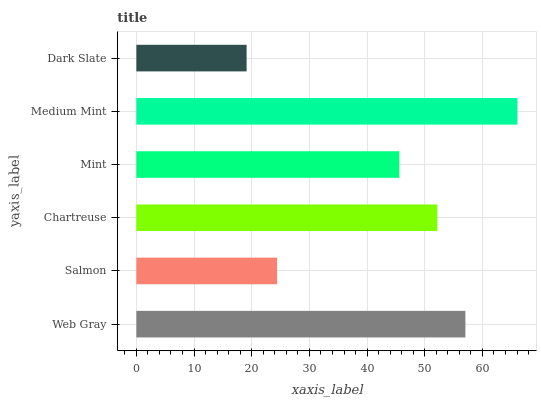Is Dark Slate the minimum?
Answer yes or no. Yes. Is Medium Mint the maximum?
Answer yes or no. Yes. Is Salmon the minimum?
Answer yes or no. No. Is Salmon the maximum?
Answer yes or no. No. Is Web Gray greater than Salmon?
Answer yes or no. Yes. Is Salmon less than Web Gray?
Answer yes or no. Yes. Is Salmon greater than Web Gray?
Answer yes or no. No. Is Web Gray less than Salmon?
Answer yes or no. No. Is Chartreuse the high median?
Answer yes or no. Yes. Is Mint the low median?
Answer yes or no. Yes. Is Web Gray the high median?
Answer yes or no. No. Is Salmon the low median?
Answer yes or no. No. 